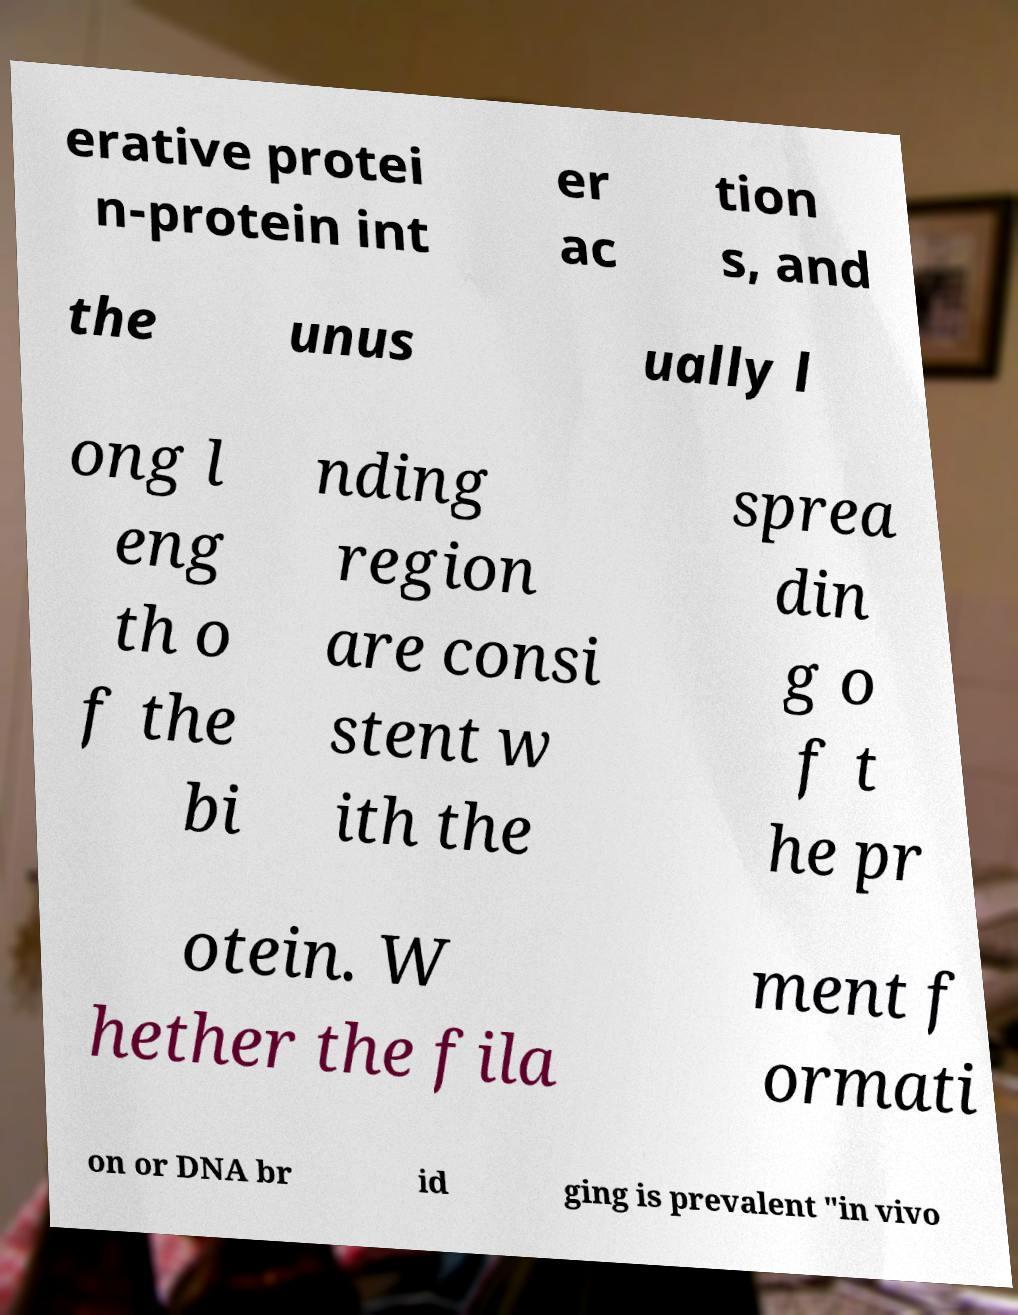Please identify and transcribe the text found in this image. erative protei n-protein int er ac tion s, and the unus ually l ong l eng th o f the bi nding region are consi stent w ith the sprea din g o f t he pr otein. W hether the fila ment f ormati on or DNA br id ging is prevalent "in vivo 